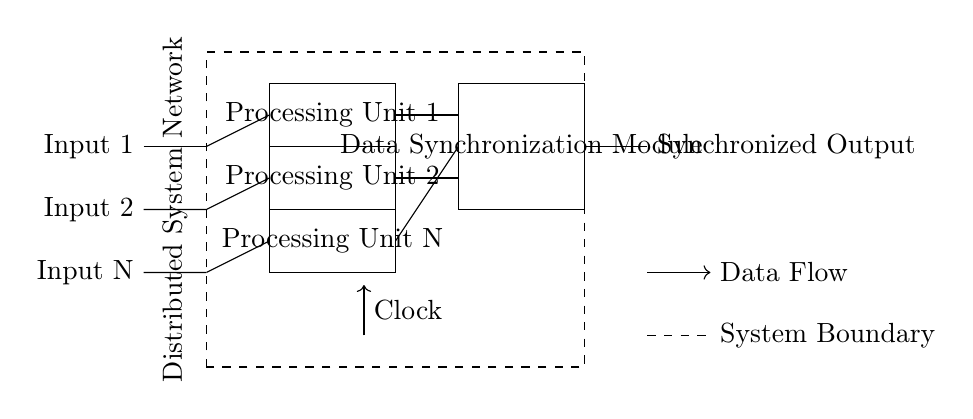What are the input data streams labeled in the circuit? The input data streams are labeled as Input 1, Input 2, and Input N. The circuit clearly shows these labels next to the corresponding input connections.
Answer: Input 1, Input 2, Input N How many processing units are there in this circuit? The circuit diagram illustrates three processing units, each marked distinctly in the rectangular boxes labeled Processing Unit 1, Processing Unit 2, and Processing Unit N.
Answer: Three What is the purpose of the Data Synchronization Module? The Data Synchronization Module's purpose is to synchronize the outputs from the processing units before they are sent out as a single output. This is inferred from its placement in the circuit, connecting directly after the processing units.
Answer: To synchronize outputs What direction is the clock signal flowing? The clock signal is indicated by an arrow, showing that it flows upward from the point marked on the diagram below to the processing units above. This direction indicates that it provides timing to the system.
Answer: Upward What type of system does this circuit belong to? The circuit is contained within a dashed rectangle labeled as the Distributed System Network. This labeling identifies the entire setup as operating within a distributed system framework.
Answer: Distributed System How many outputs does the circuit generate? There is one output labeled Synchronized Output at the far right side of the circuit. This indicates that all processed data is consolidated into a single output stream.
Answer: One What does the dashed line around the circuit represent? The dashed line around the circuit indicates the system boundary, distinguishing internal components and connections from external elements or systems. This separation clarifies what is included in the described system.
Answer: System Boundary 